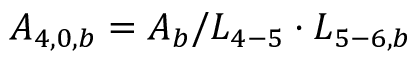Convert formula to latex. <formula><loc_0><loc_0><loc_500><loc_500>{ A _ { 4 , 0 , b } } = { A _ { b } } / { L _ { 4 - 5 } } \cdot { L _ { 5 - 6 , b } }</formula> 